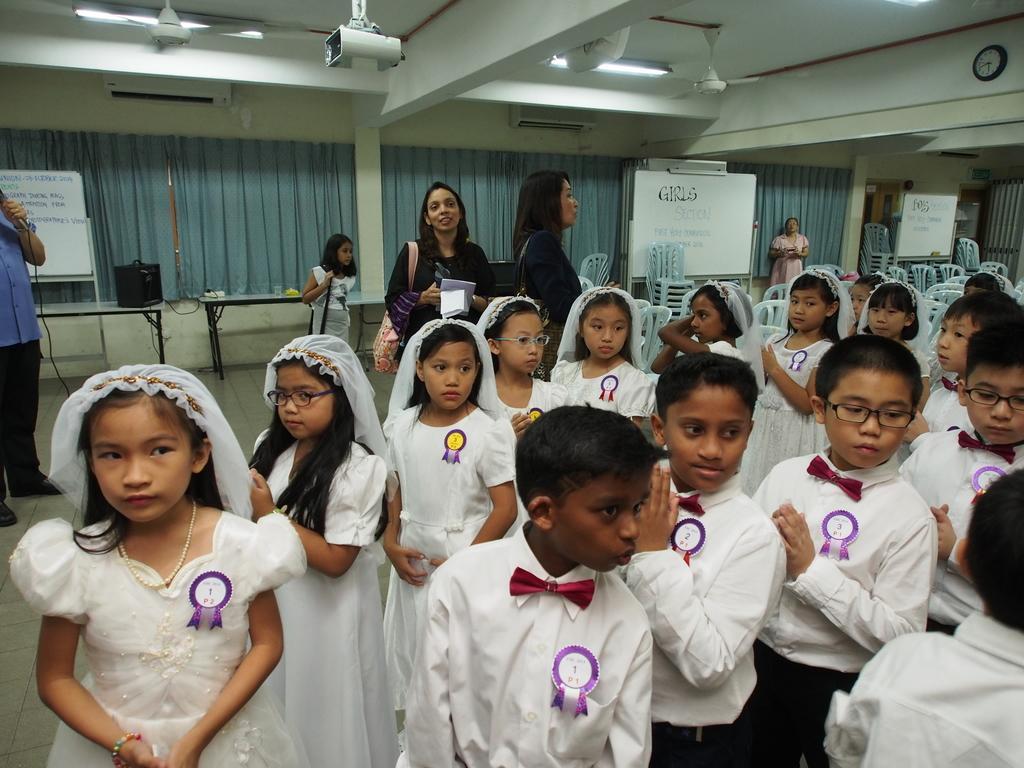Please provide a concise description of this image. In this image we can see few girls and boys. Some are wearing specs. Girls are wearing veils. And they are having badge. In the back few persons are standing. One lady is holding something in the hand. Also having a bag. Person on the left side is holding a mic. In the back there are boards. Also there are chairs. On the ceiling there are fans and lights. Also there is a projector. And there is a clock on the wall. In the back there are curtains. And there is a speaker on the table. And there are tables. 